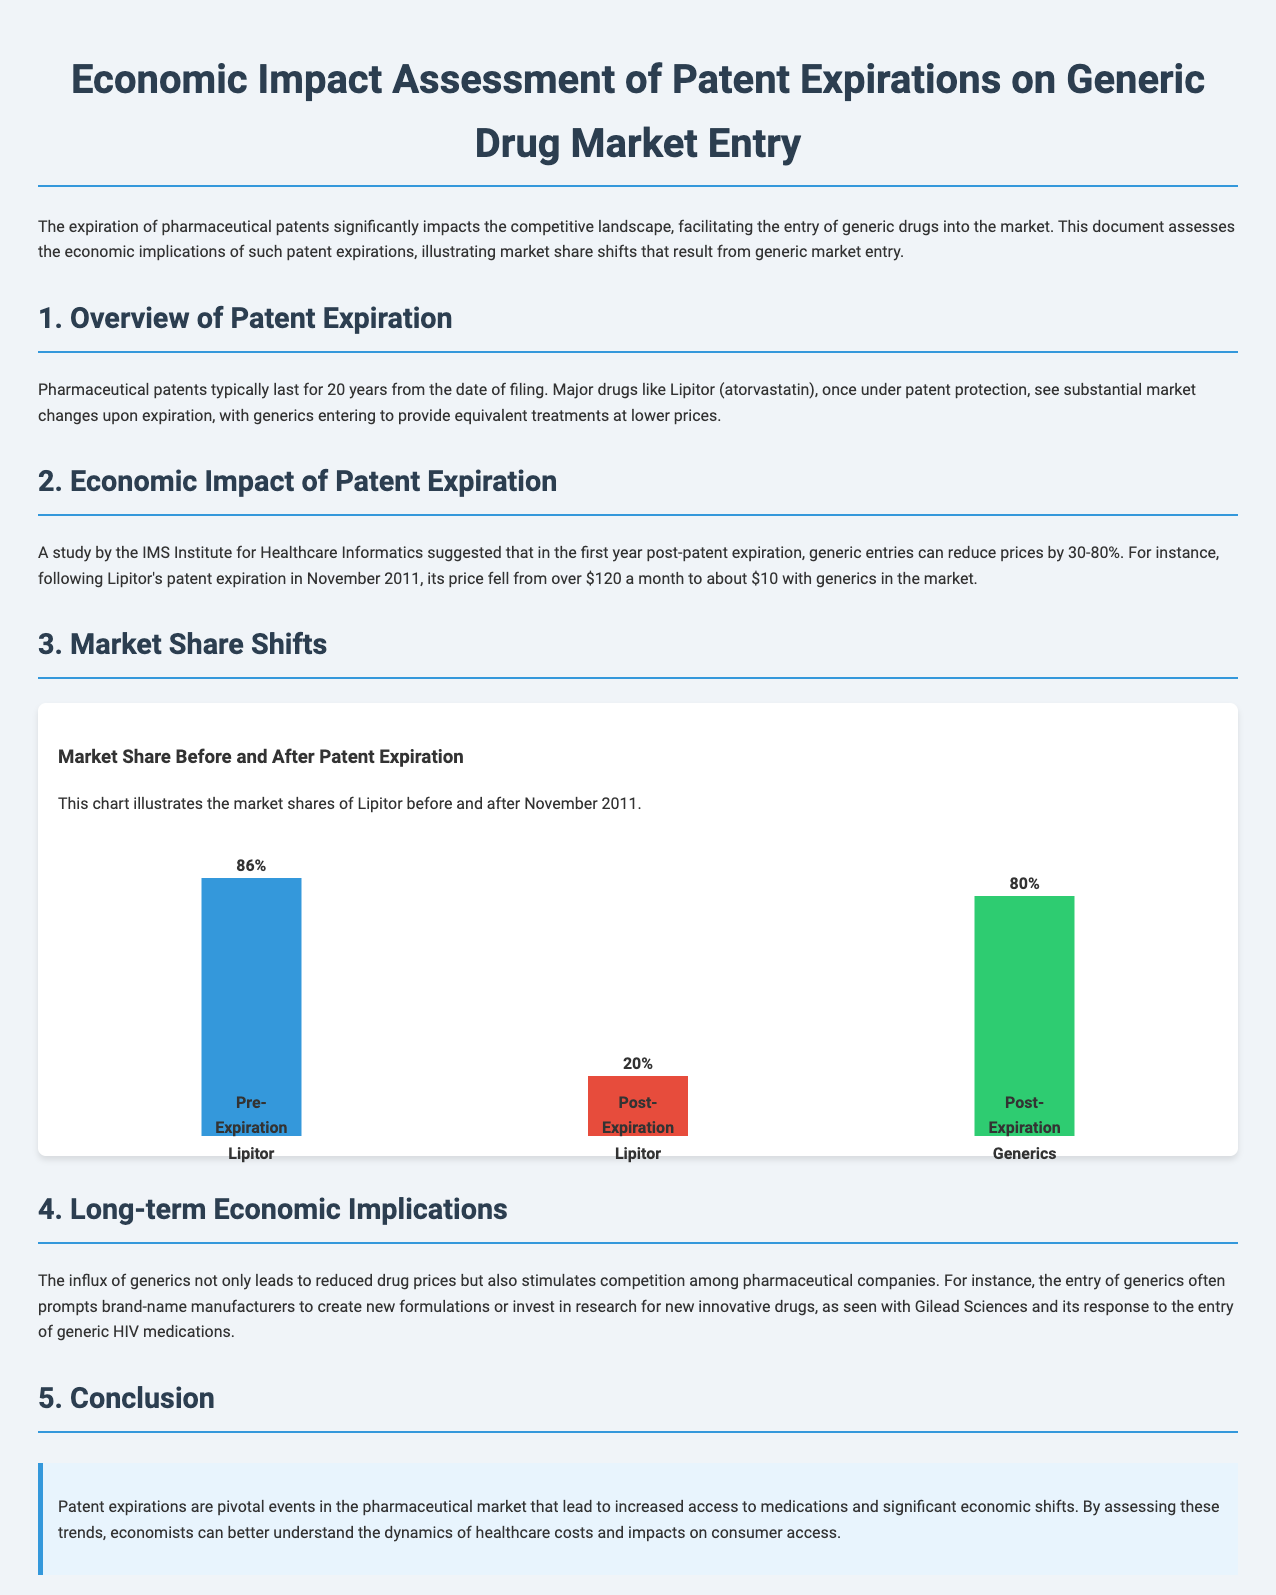What is the title of the document? The title is stated at the top of the document, providing a focus on economic impact assessment regarding patent expirations and generic drugs.
Answer: Economic Impact Assessment of Patent Expirations on Generic Drug Market Entry Who conducted the study on price reductions post-patent expiration? The source of the study is specified in the document as the IMS Institute for Healthcare Informatics, which analyzed the impact of generics on pricing.
Answer: IMS Institute for Healthcare Informatics What percentage did Lipitor's market share drop to after patent expiration? The bar chart illustrates that Lipitor's market share dropped from 86% to 20% after patent expiration, showing a significant market shift.
Answer: 20% What was the price of Lipitor before generics entered the market? The document indicates that the price of Lipitor was over $120 a month prior to generic market entry, highlighting the cost impact of patent expiration.
Answer: over $120 What market share percentage is attributed to generics post-expiration? The chart shows generics capturing 80% of the market share after Lipitor's patent expiration, indicating the dominance of generics in the market.
Answer: 80% According to the document, what is a long-term effect of generic drug market entry? The text mentions that an influx of generics stimulates competition among pharmaceutical companies leading to innovations and new formulations as seen in specific industry cases.
Answer: stimulates competition What year did Lipitor's patent expire? The document specifically states that Lipitor's patent expired in November 2011, marking a significant date in the context of drug pricing and competition.
Answer: November 2011 What color represents the post-expiration share of generics in the chart? The document provides information on the chart's color coding, indicating that green represents the post-expiration share of generics effectively.
Answer: green 